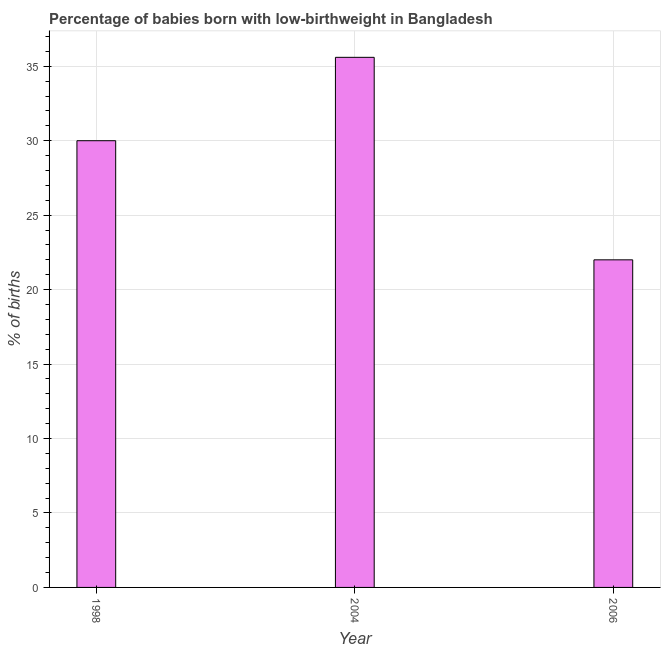Does the graph contain grids?
Provide a short and direct response. Yes. What is the title of the graph?
Keep it short and to the point. Percentage of babies born with low-birthweight in Bangladesh. What is the label or title of the X-axis?
Your response must be concise. Year. What is the label or title of the Y-axis?
Keep it short and to the point. % of births. Across all years, what is the maximum percentage of babies who were born with low-birthweight?
Provide a short and direct response. 35.6. In which year was the percentage of babies who were born with low-birthweight maximum?
Offer a terse response. 2004. In which year was the percentage of babies who were born with low-birthweight minimum?
Your answer should be very brief. 2006. What is the sum of the percentage of babies who were born with low-birthweight?
Provide a short and direct response. 87.6. What is the difference between the percentage of babies who were born with low-birthweight in 1998 and 2006?
Your answer should be very brief. 8. What is the average percentage of babies who were born with low-birthweight per year?
Ensure brevity in your answer.  29.2. What is the ratio of the percentage of babies who were born with low-birthweight in 1998 to that in 2004?
Provide a short and direct response. 0.84. Is the difference between the percentage of babies who were born with low-birthweight in 1998 and 2004 greater than the difference between any two years?
Give a very brief answer. No. How many bars are there?
Offer a very short reply. 3. Are the values on the major ticks of Y-axis written in scientific E-notation?
Your answer should be very brief. No. What is the % of births of 1998?
Keep it short and to the point. 30. What is the % of births of 2004?
Provide a short and direct response. 35.6. What is the % of births in 2006?
Provide a succinct answer. 22. What is the difference between the % of births in 1998 and 2006?
Offer a terse response. 8. What is the difference between the % of births in 2004 and 2006?
Provide a short and direct response. 13.6. What is the ratio of the % of births in 1998 to that in 2004?
Offer a very short reply. 0.84. What is the ratio of the % of births in 1998 to that in 2006?
Make the answer very short. 1.36. What is the ratio of the % of births in 2004 to that in 2006?
Provide a succinct answer. 1.62. 